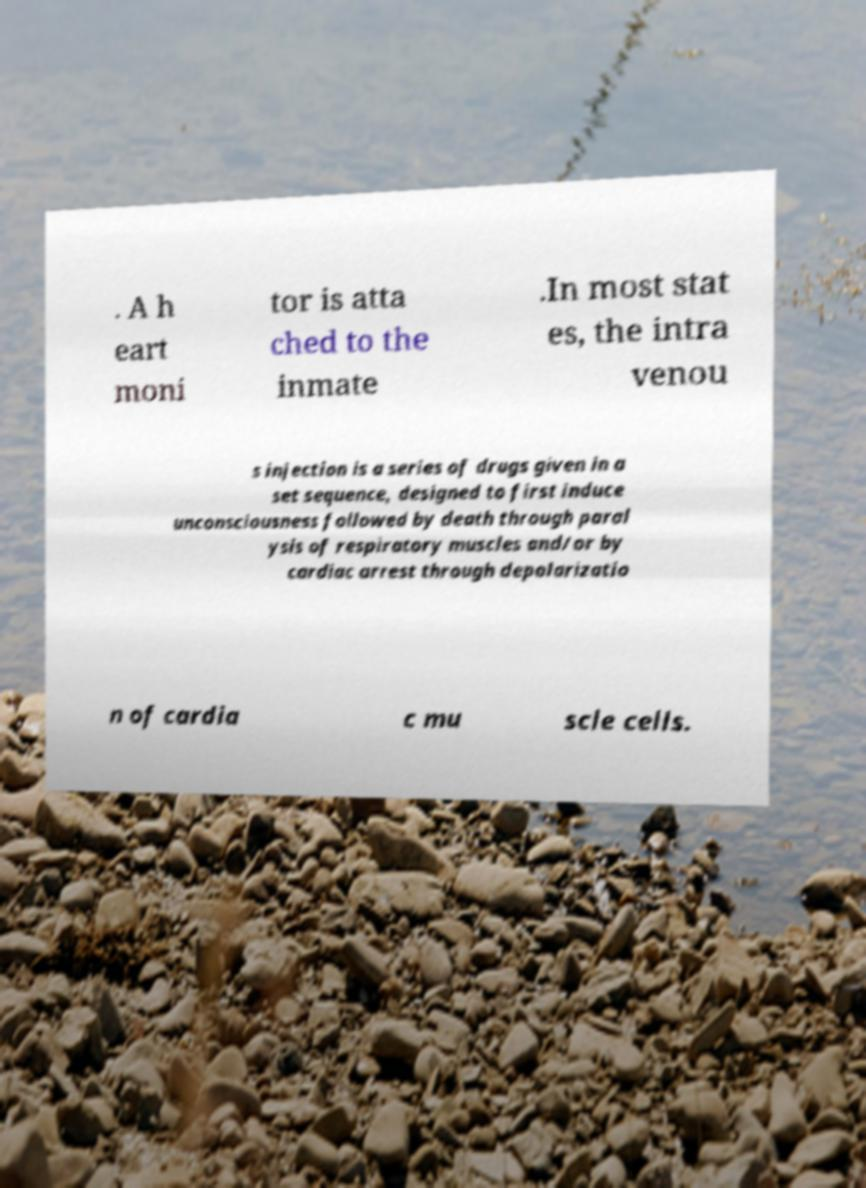Can you accurately transcribe the text from the provided image for me? . A h eart moni tor is atta ched to the inmate .In most stat es, the intra venou s injection is a series of drugs given in a set sequence, designed to first induce unconsciousness followed by death through paral ysis of respiratory muscles and/or by cardiac arrest through depolarizatio n of cardia c mu scle cells. 